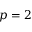Convert formula to latex. <formula><loc_0><loc_0><loc_500><loc_500>p = 2</formula> 